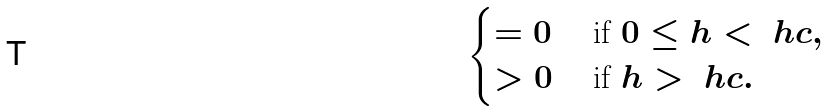Convert formula to latex. <formula><loc_0><loc_0><loc_500><loc_500>\begin{cases} = 0 & \text { if } 0 \leq h < \ h c , \\ > 0 & \text { if } h > \ h c . \end{cases}</formula> 